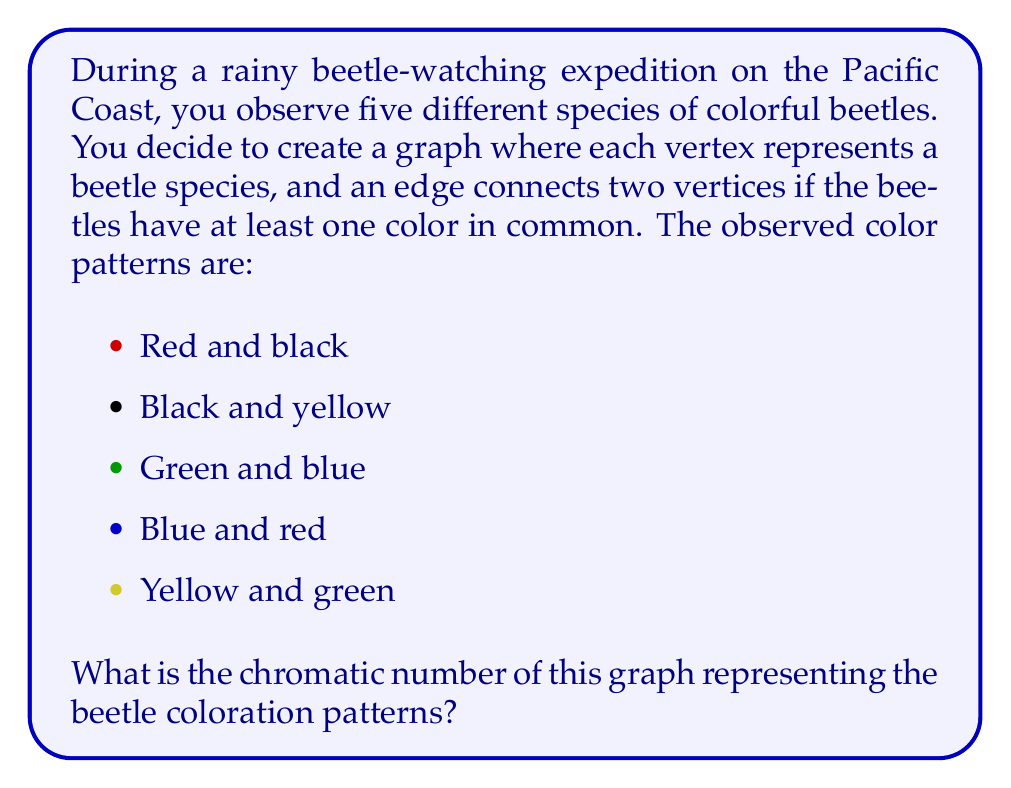Can you answer this question? Let's approach this step-by-step:

1) First, we need to construct the graph based on the given information:
   - We have 5 vertices, each representing a beetle species.
   - We connect two vertices with an edge if they share at least one color.

2) Let's identify the connections:
   - 1 and 2 are connected (black)
   - 1 and 4 are connected (red)
   - 2 and 5 are connected (yellow)
   - 3 and 4 are connected (blue)
   - 3 and 5 are connected (green)

3) Now we have our graph. To find the chromatic number, we need to color the vertices such that no two adjacent vertices have the same color, using the minimum number of colors possible.

4) Let's attempt to color the graph:
   - Start with vertex 1: Color it red
   - Vertex 2 is adjacent to 1, so it needs a different color: Color it blue
   - Vertex 3 is not adjacent to 1 or 2, so we can use red again
   - Vertex 4 is adjacent to 1 and 3, so it needs a new color: Color it green
   - Vertex 5 is adjacent to 2 and 3, so it needs a new color: Color it yellow

5) We've successfully colored the graph using 4 colors, and it's not possible to do it with fewer colors because:
   - Vertices 1, 2, 4, and 5 form a cycle of length 4, which requires at least 2 colors
   - Vertex 3 is connected to both 4 and 5, necessitating a third color
   - Vertex 1 is connected to both 2 and 4, requiring a fourth color

Therefore, the chromatic number of this graph is 4.
Answer: The chromatic number of the graph representing the beetle coloration patterns is 4. 